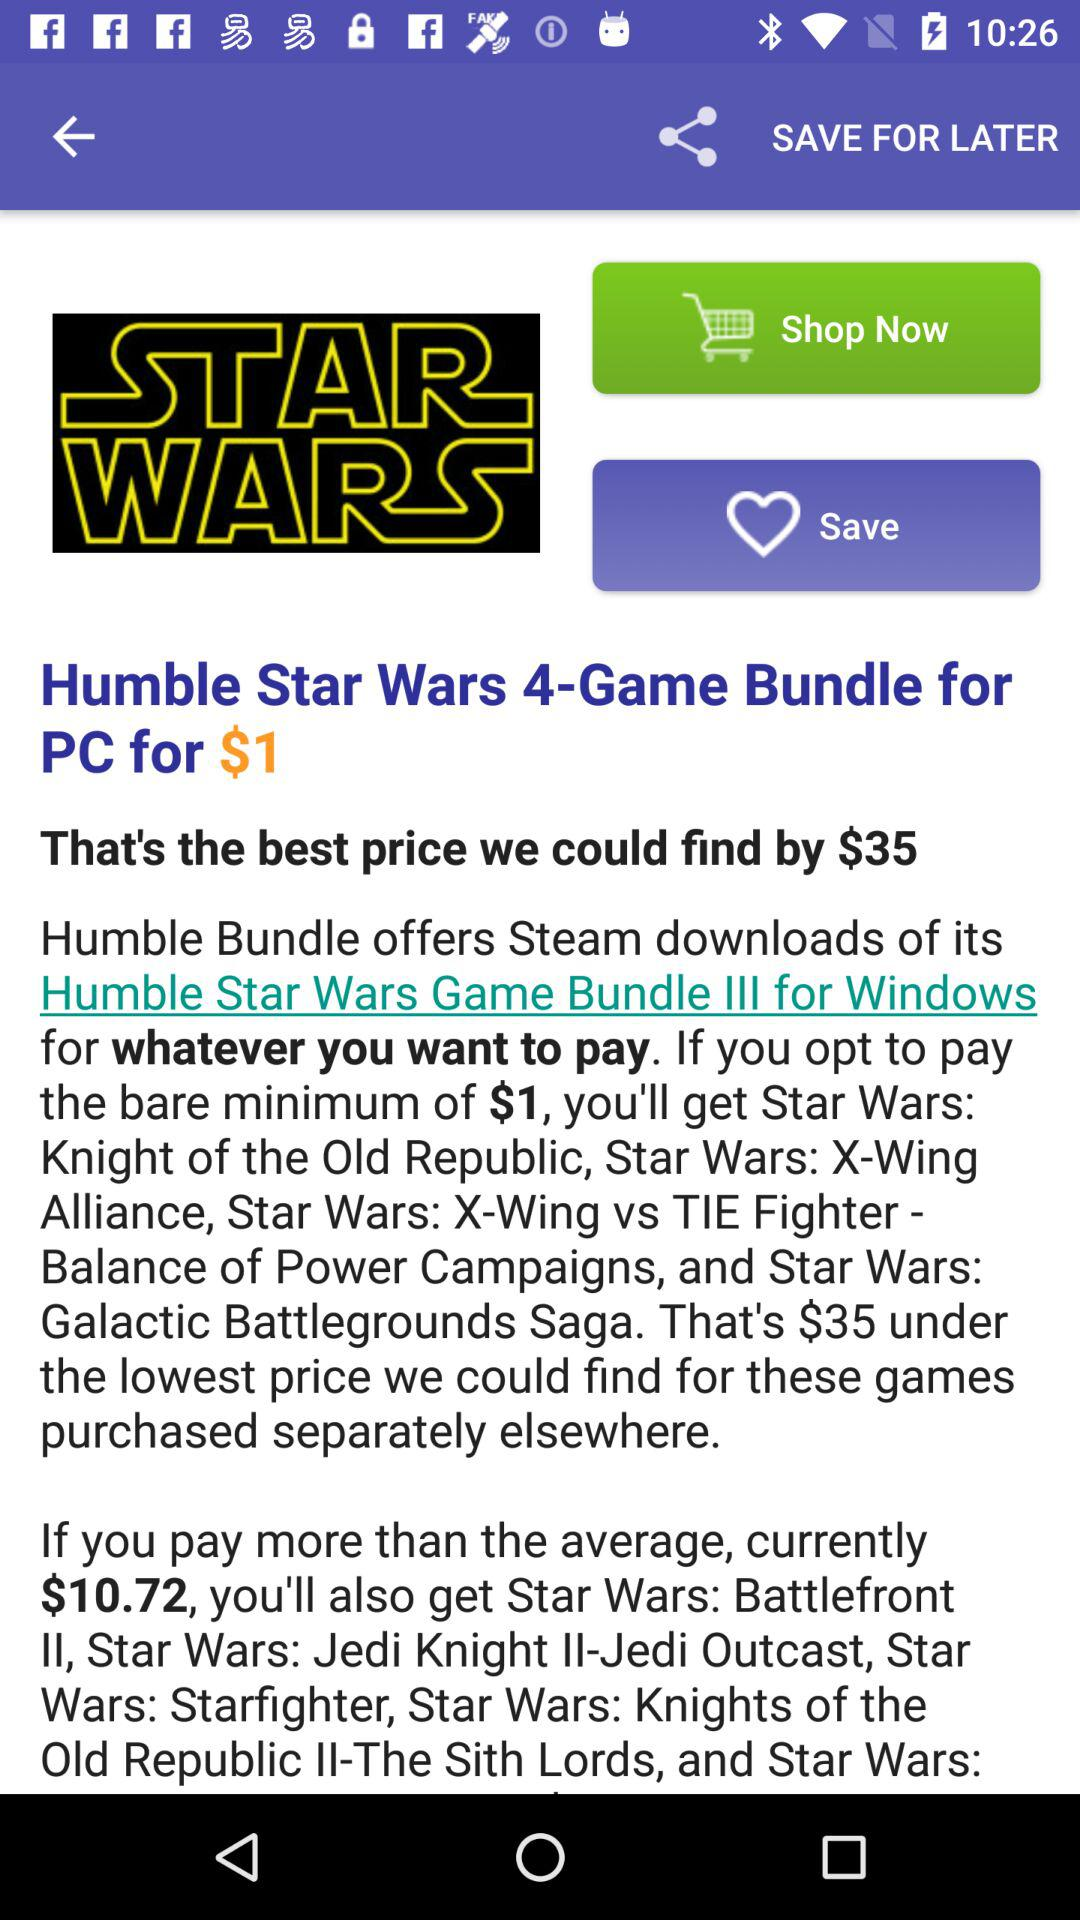What is the name of the game? The name of the game is "STAR WARS". 